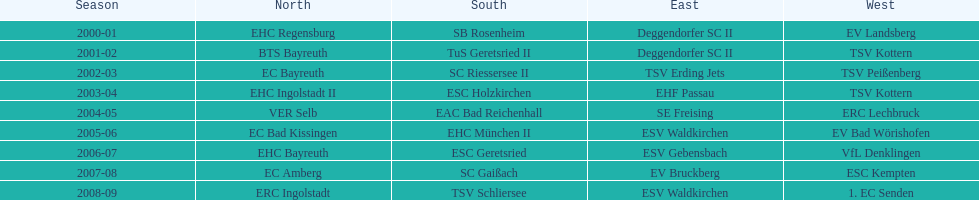Starting with the 2007 - 08 season, does ecs kempten appear in any of the previous years? No. 